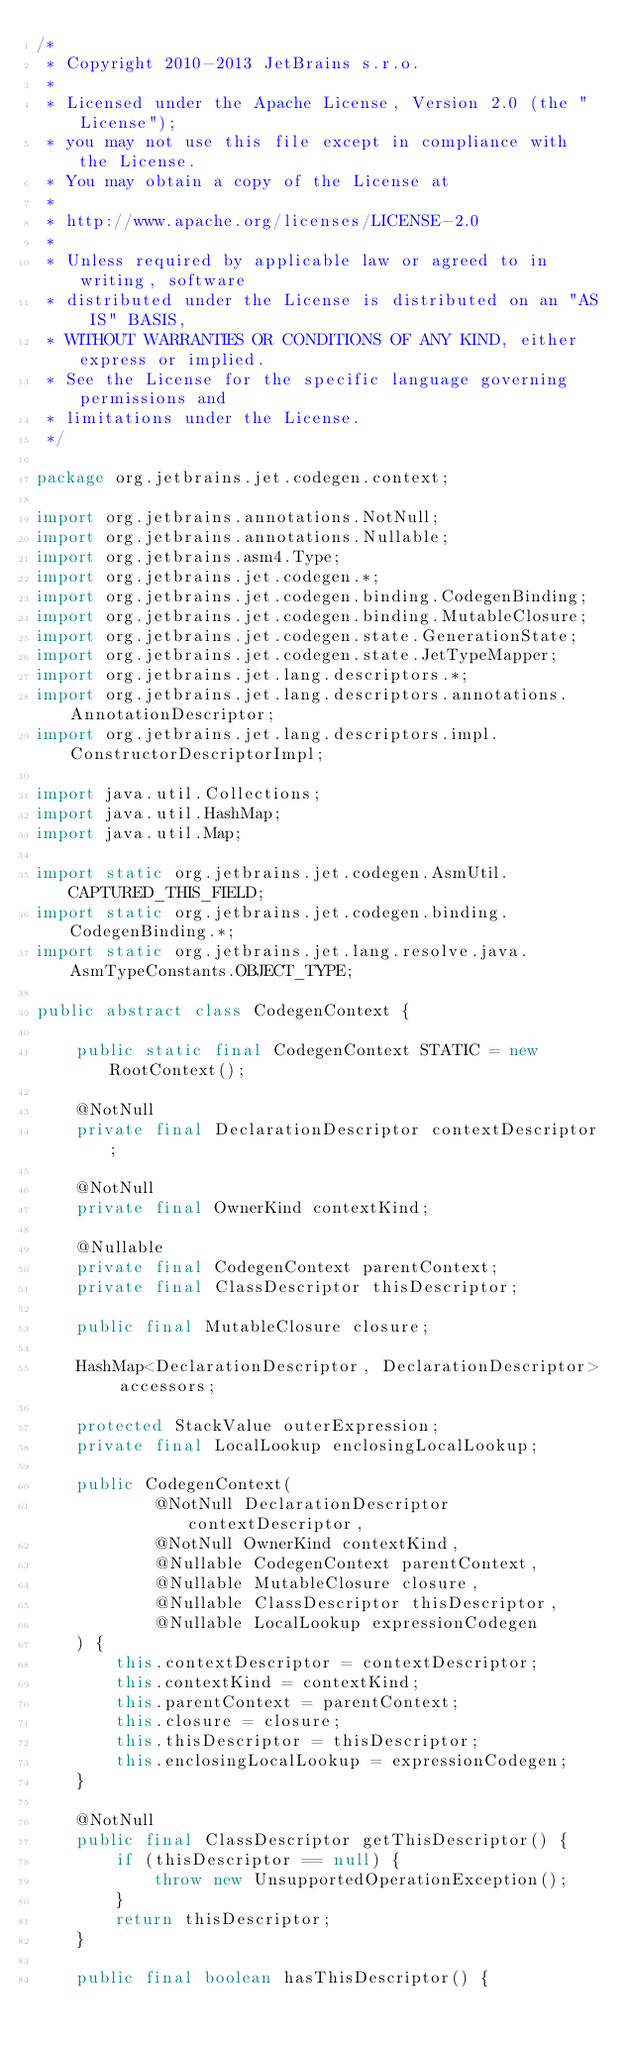Convert code to text. <code><loc_0><loc_0><loc_500><loc_500><_Java_>/*
 * Copyright 2010-2013 JetBrains s.r.o.
 *
 * Licensed under the Apache License, Version 2.0 (the "License");
 * you may not use this file except in compliance with the License.
 * You may obtain a copy of the License at
 *
 * http://www.apache.org/licenses/LICENSE-2.0
 *
 * Unless required by applicable law or agreed to in writing, software
 * distributed under the License is distributed on an "AS IS" BASIS,
 * WITHOUT WARRANTIES OR CONDITIONS OF ANY KIND, either express or implied.
 * See the License for the specific language governing permissions and
 * limitations under the License.
 */

package org.jetbrains.jet.codegen.context;

import org.jetbrains.annotations.NotNull;
import org.jetbrains.annotations.Nullable;
import org.jetbrains.asm4.Type;
import org.jetbrains.jet.codegen.*;
import org.jetbrains.jet.codegen.binding.CodegenBinding;
import org.jetbrains.jet.codegen.binding.MutableClosure;
import org.jetbrains.jet.codegen.state.GenerationState;
import org.jetbrains.jet.codegen.state.JetTypeMapper;
import org.jetbrains.jet.lang.descriptors.*;
import org.jetbrains.jet.lang.descriptors.annotations.AnnotationDescriptor;
import org.jetbrains.jet.lang.descriptors.impl.ConstructorDescriptorImpl;

import java.util.Collections;
import java.util.HashMap;
import java.util.Map;

import static org.jetbrains.jet.codegen.AsmUtil.CAPTURED_THIS_FIELD;
import static org.jetbrains.jet.codegen.binding.CodegenBinding.*;
import static org.jetbrains.jet.lang.resolve.java.AsmTypeConstants.OBJECT_TYPE;

public abstract class CodegenContext {

    public static final CodegenContext STATIC = new RootContext();

    @NotNull
    private final DeclarationDescriptor contextDescriptor;

    @NotNull
    private final OwnerKind contextKind;

    @Nullable
    private final CodegenContext parentContext;
    private final ClassDescriptor thisDescriptor;

    public final MutableClosure closure;

    HashMap<DeclarationDescriptor, DeclarationDescriptor> accessors;

    protected StackValue outerExpression;
    private final LocalLookup enclosingLocalLookup;

    public CodegenContext(
            @NotNull DeclarationDescriptor contextDescriptor,
            @NotNull OwnerKind contextKind,
            @Nullable CodegenContext parentContext,
            @Nullable MutableClosure closure,
            @Nullable ClassDescriptor thisDescriptor,
            @Nullable LocalLookup expressionCodegen
    ) {
        this.contextDescriptor = contextDescriptor;
        this.contextKind = contextKind;
        this.parentContext = parentContext;
        this.closure = closure;
        this.thisDescriptor = thisDescriptor;
        this.enclosingLocalLookup = expressionCodegen;
    }

    @NotNull
    public final ClassDescriptor getThisDescriptor() {
        if (thisDescriptor == null) {
            throw new UnsupportedOperationException();
        }
        return thisDescriptor;
    }

    public final boolean hasThisDescriptor() {</code> 